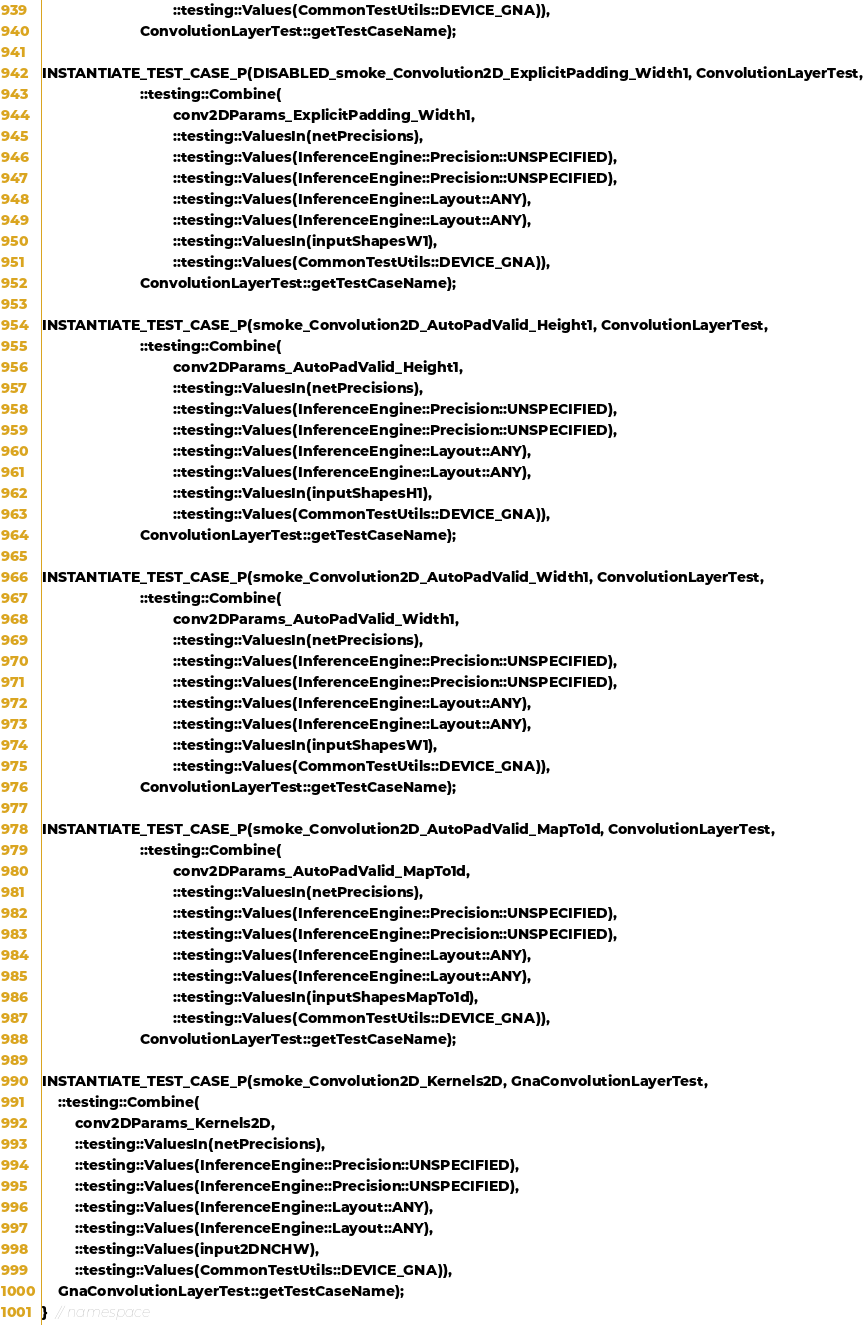<code> <loc_0><loc_0><loc_500><loc_500><_C++_>                                ::testing::Values(CommonTestUtils::DEVICE_GNA)),
                        ConvolutionLayerTest::getTestCaseName);

INSTANTIATE_TEST_CASE_P(DISABLED_smoke_Convolution2D_ExplicitPadding_Width1, ConvolutionLayerTest,
                        ::testing::Combine(
                                conv2DParams_ExplicitPadding_Width1,
                                ::testing::ValuesIn(netPrecisions),
                                ::testing::Values(InferenceEngine::Precision::UNSPECIFIED),
                                ::testing::Values(InferenceEngine::Precision::UNSPECIFIED),
                                ::testing::Values(InferenceEngine::Layout::ANY),
                                ::testing::Values(InferenceEngine::Layout::ANY),
                                ::testing::ValuesIn(inputShapesW1),
                                ::testing::Values(CommonTestUtils::DEVICE_GNA)),
                        ConvolutionLayerTest::getTestCaseName);

INSTANTIATE_TEST_CASE_P(smoke_Convolution2D_AutoPadValid_Height1, ConvolutionLayerTest,
                        ::testing::Combine(
                                conv2DParams_AutoPadValid_Height1,
                                ::testing::ValuesIn(netPrecisions),
                                ::testing::Values(InferenceEngine::Precision::UNSPECIFIED),
                                ::testing::Values(InferenceEngine::Precision::UNSPECIFIED),
                                ::testing::Values(InferenceEngine::Layout::ANY),
                                ::testing::Values(InferenceEngine::Layout::ANY),
                                ::testing::ValuesIn(inputShapesH1),
                                ::testing::Values(CommonTestUtils::DEVICE_GNA)),
                        ConvolutionLayerTest::getTestCaseName);

INSTANTIATE_TEST_CASE_P(smoke_Convolution2D_AutoPadValid_Width1, ConvolutionLayerTest,
                        ::testing::Combine(
                                conv2DParams_AutoPadValid_Width1,
                                ::testing::ValuesIn(netPrecisions),
                                ::testing::Values(InferenceEngine::Precision::UNSPECIFIED),
                                ::testing::Values(InferenceEngine::Precision::UNSPECIFIED),
                                ::testing::Values(InferenceEngine::Layout::ANY),
                                ::testing::Values(InferenceEngine::Layout::ANY),
                                ::testing::ValuesIn(inputShapesW1),
                                ::testing::Values(CommonTestUtils::DEVICE_GNA)),
                        ConvolutionLayerTest::getTestCaseName);

INSTANTIATE_TEST_CASE_P(smoke_Convolution2D_AutoPadValid_MapTo1d, ConvolutionLayerTest,
                        ::testing::Combine(
                                conv2DParams_AutoPadValid_MapTo1d,
                                ::testing::ValuesIn(netPrecisions),
                                ::testing::Values(InferenceEngine::Precision::UNSPECIFIED),
                                ::testing::Values(InferenceEngine::Precision::UNSPECIFIED),
                                ::testing::Values(InferenceEngine::Layout::ANY),
                                ::testing::Values(InferenceEngine::Layout::ANY),
                                ::testing::ValuesIn(inputShapesMapTo1d),
                                ::testing::Values(CommonTestUtils::DEVICE_GNA)),
                        ConvolutionLayerTest::getTestCaseName);

INSTANTIATE_TEST_CASE_P(smoke_Convolution2D_Kernels2D, GnaConvolutionLayerTest,
    ::testing::Combine(
        conv2DParams_Kernels2D,
        ::testing::ValuesIn(netPrecisions),
        ::testing::Values(InferenceEngine::Precision::UNSPECIFIED),
        ::testing::Values(InferenceEngine::Precision::UNSPECIFIED),
        ::testing::Values(InferenceEngine::Layout::ANY),
        ::testing::Values(InferenceEngine::Layout::ANY),
        ::testing::Values(input2DNCHW),
        ::testing::Values(CommonTestUtils::DEVICE_GNA)),
    GnaConvolutionLayerTest::getTestCaseName);
}  // namespace
</code> 